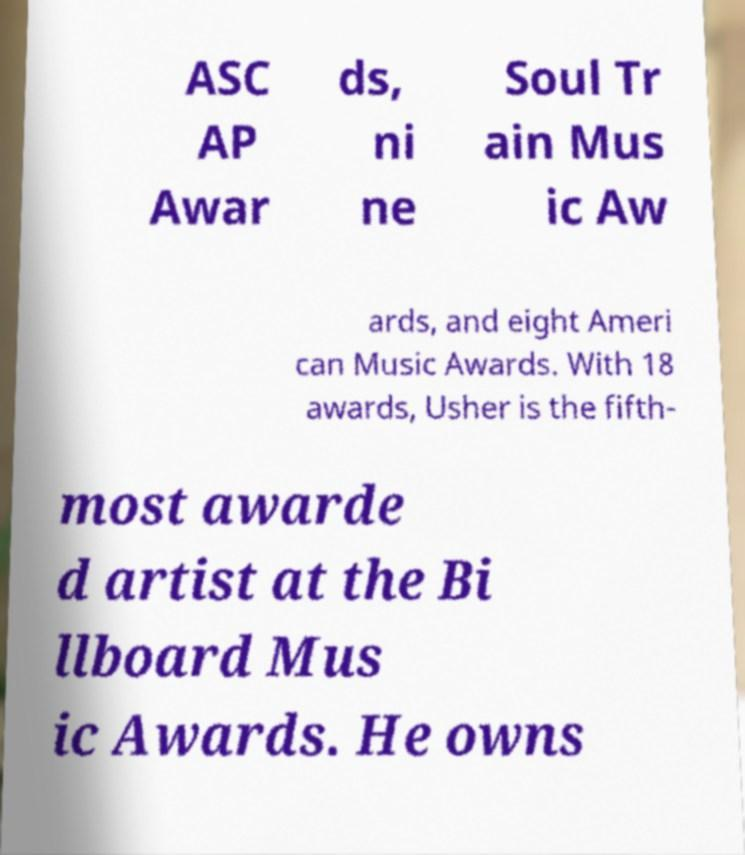There's text embedded in this image that I need extracted. Can you transcribe it verbatim? ASC AP Awar ds, ni ne Soul Tr ain Mus ic Aw ards, and eight Ameri can Music Awards. With 18 awards, Usher is the fifth- most awarde d artist at the Bi llboard Mus ic Awards. He owns 